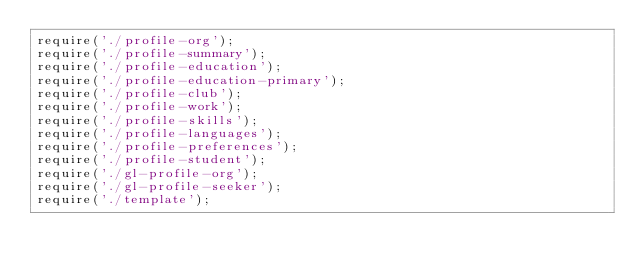Convert code to text. <code><loc_0><loc_0><loc_500><loc_500><_JavaScript_>require('./profile-org');
require('./profile-summary');
require('./profile-education');
require('./profile-education-primary');
require('./profile-club');
require('./profile-work');
require('./profile-skills');
require('./profile-languages');
require('./profile-preferences');
require('./profile-student');
require('./gl-profile-org');
require('./gl-profile-seeker');
require('./template');
</code> 